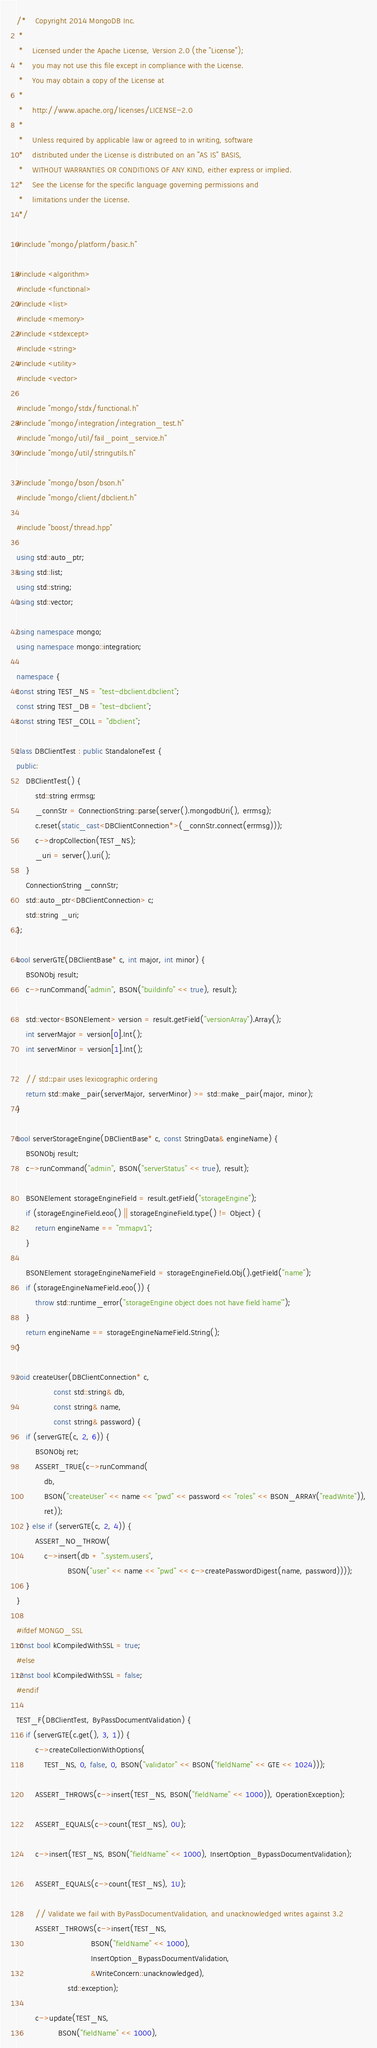<code> <loc_0><loc_0><loc_500><loc_500><_C++_>/*    Copyright 2014 MongoDB Inc.
 *
 *    Licensed under the Apache License, Version 2.0 (the "License");
 *    you may not use this file except in compliance with the License.
 *    You may obtain a copy of the License at
 *
 *    http://www.apache.org/licenses/LICENSE-2.0
 *
 *    Unless required by applicable law or agreed to in writing, software
 *    distributed under the License is distributed on an "AS IS" BASIS,
 *    WITHOUT WARRANTIES OR CONDITIONS OF ANY KIND, either express or implied.
 *    See the License for the specific language governing permissions and
 *    limitations under the License.
 */

#include "mongo/platform/basic.h"

#include <algorithm>
#include <functional>
#include <list>
#include <memory>
#include <stdexcept>
#include <string>
#include <utility>
#include <vector>

#include "mongo/stdx/functional.h"
#include "mongo/integration/integration_test.h"
#include "mongo/util/fail_point_service.h"
#include "mongo/util/stringutils.h"

#include "mongo/bson/bson.h"
#include "mongo/client/dbclient.h"

#include "boost/thread.hpp"

using std::auto_ptr;
using std::list;
using std::string;
using std::vector;

using namespace mongo;
using namespace mongo::integration;

namespace {
const string TEST_NS = "test-dbclient.dbclient";
const string TEST_DB = "test-dbclient";
const string TEST_COLL = "dbclient";

class DBClientTest : public StandaloneTest {
public:
    DBClientTest() {
        std::string errmsg;
        _connStr = ConnectionString::parse(server().mongodbUri(), errmsg);
        c.reset(static_cast<DBClientConnection*>(_connStr.connect(errmsg)));
        c->dropCollection(TEST_NS);
        _uri = server().uri();
    }
    ConnectionString _connStr;
    std::auto_ptr<DBClientConnection> c;
    std::string _uri;
};

bool serverGTE(DBClientBase* c, int major, int minor) {
    BSONObj result;
    c->runCommand("admin", BSON("buildinfo" << true), result);

    std::vector<BSONElement> version = result.getField("versionArray").Array();
    int serverMajor = version[0].Int();
    int serverMinor = version[1].Int();

    // std::pair uses lexicographic ordering
    return std::make_pair(serverMajor, serverMinor) >= std::make_pair(major, minor);
}

bool serverStorageEngine(DBClientBase* c, const StringData& engineName) {
    BSONObj result;
    c->runCommand("admin", BSON("serverStatus" << true), result);

    BSONElement storageEngineField = result.getField("storageEngine");
    if (storageEngineField.eoo() || storageEngineField.type() != Object) {
        return engineName == "mmapv1";
    }

    BSONElement storageEngineNameField = storageEngineField.Obj().getField("name");
    if (storageEngineNameField.eoo()) {
        throw std::runtime_error("storageEngine object does not have field `name`");
    }
    return engineName == storageEngineNameField.String();
}

void createUser(DBClientConnection* c,
                const std::string& db,
                const string& name,
                const string& password) {
    if (serverGTE(c, 2, 6)) {
        BSONObj ret;
        ASSERT_TRUE(c->runCommand(
            db,
            BSON("createUser" << name << "pwd" << password << "roles" << BSON_ARRAY("readWrite")),
            ret));
    } else if (serverGTE(c, 2, 4)) {
        ASSERT_NO_THROW(
            c->insert(db + ".system.users",
                      BSON("user" << name << "pwd" << c->createPasswordDigest(name, password))));
    }
}

#ifdef MONGO_SSL
const bool kCompiledWithSSL = true;
#else
const bool kCompiledWithSSL = false;
#endif

TEST_F(DBClientTest, ByPassDocumentValidation) {
    if (serverGTE(c.get(), 3, 1)) {
        c->createCollectionWithOptions(
            TEST_NS, 0, false, 0, BSON("validator" << BSON("fieldName" << GTE << 1024)));

        ASSERT_THROWS(c->insert(TEST_NS, BSON("fieldName" << 1000)), OperationException);

        ASSERT_EQUALS(c->count(TEST_NS), 0U);

        c->insert(TEST_NS, BSON("fieldName" << 1000), InsertOption_BypassDocumentValidation);

        ASSERT_EQUALS(c->count(TEST_NS), 1U);

        // Validate we fail with ByPassDocumentValidation, and unacknowledged writes against 3.2
        ASSERT_THROWS(c->insert(TEST_NS,
                                BSON("fieldName" << 1000),
                                InsertOption_BypassDocumentValidation,
                                &WriteConcern::unacknowledged),
                      std::exception);

        c->update(TEST_NS,
                  BSON("fieldName" << 1000),</code> 